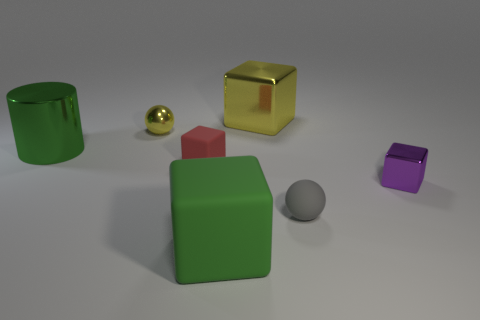Can you describe the lighting in the scene? The lighting in the image is soft and diffused, creating gentle shadows to the right of the objects and giving the scene a calm and balanced atmosphere. 